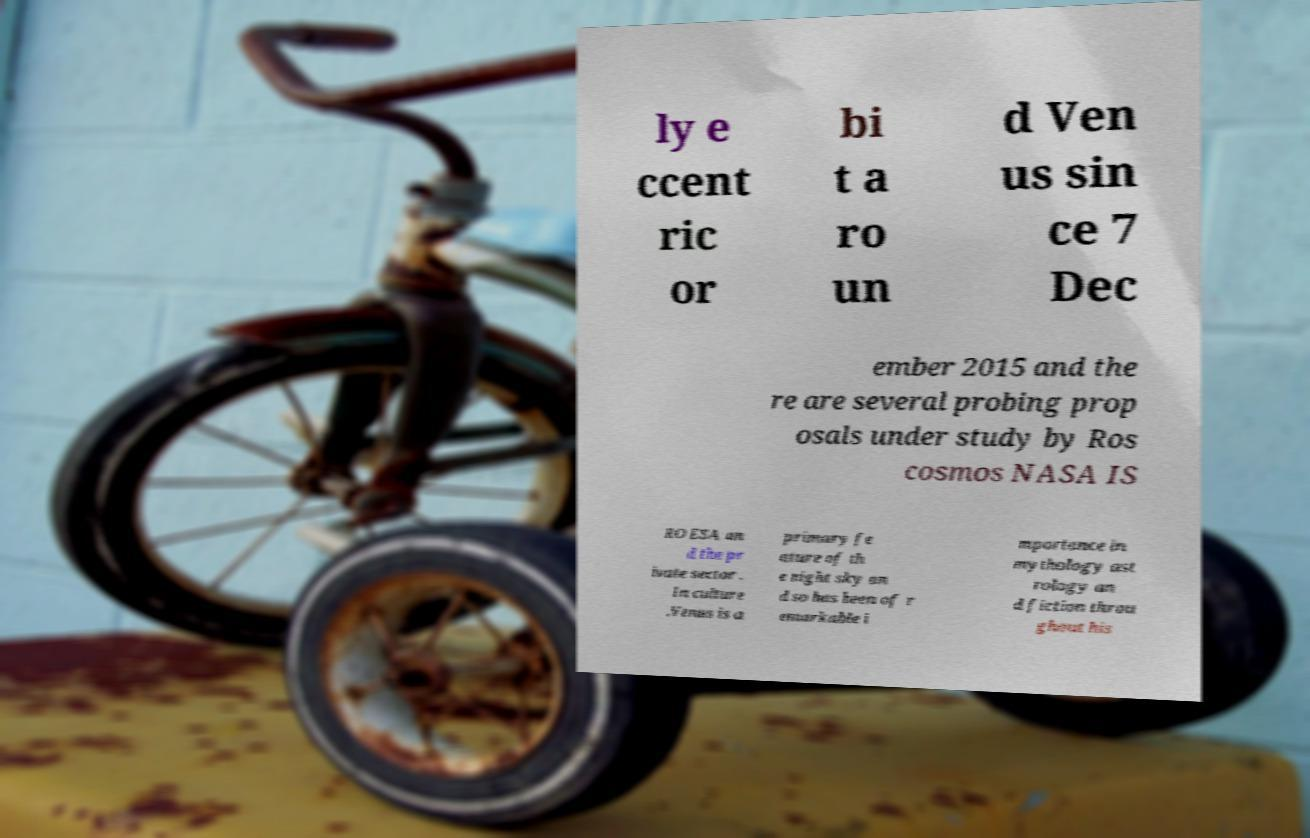Please identify and transcribe the text found in this image. ly e ccent ric or bi t a ro un d Ven us sin ce 7 Dec ember 2015 and the re are several probing prop osals under study by Ros cosmos NASA IS RO ESA an d the pr ivate sector . In culture .Venus is a primary fe ature of th e night sky an d so has been of r emarkable i mportance in mythology ast rology an d fiction throu ghout his 